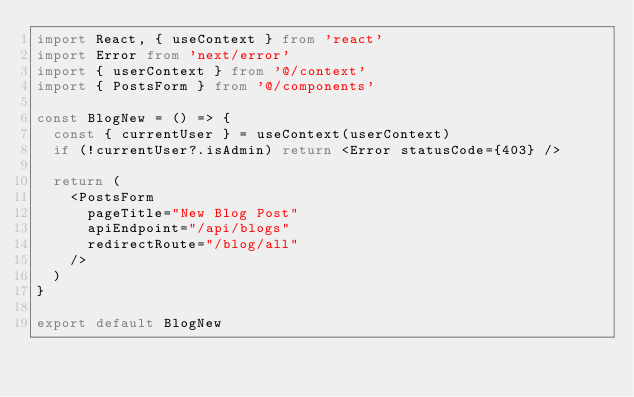Convert code to text. <code><loc_0><loc_0><loc_500><loc_500><_TypeScript_>import React, { useContext } from 'react'
import Error from 'next/error'
import { userContext } from '@/context'
import { PostsForm } from '@/components'

const BlogNew = () => {
  const { currentUser } = useContext(userContext)
  if (!currentUser?.isAdmin) return <Error statusCode={403} />

  return (
    <PostsForm
      pageTitle="New Blog Post"
      apiEndpoint="/api/blogs"
      redirectRoute="/blog/all"
    />
  )
}

export default BlogNew
</code> 